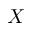Convert formula to latex. <formula><loc_0><loc_0><loc_500><loc_500>X</formula> 